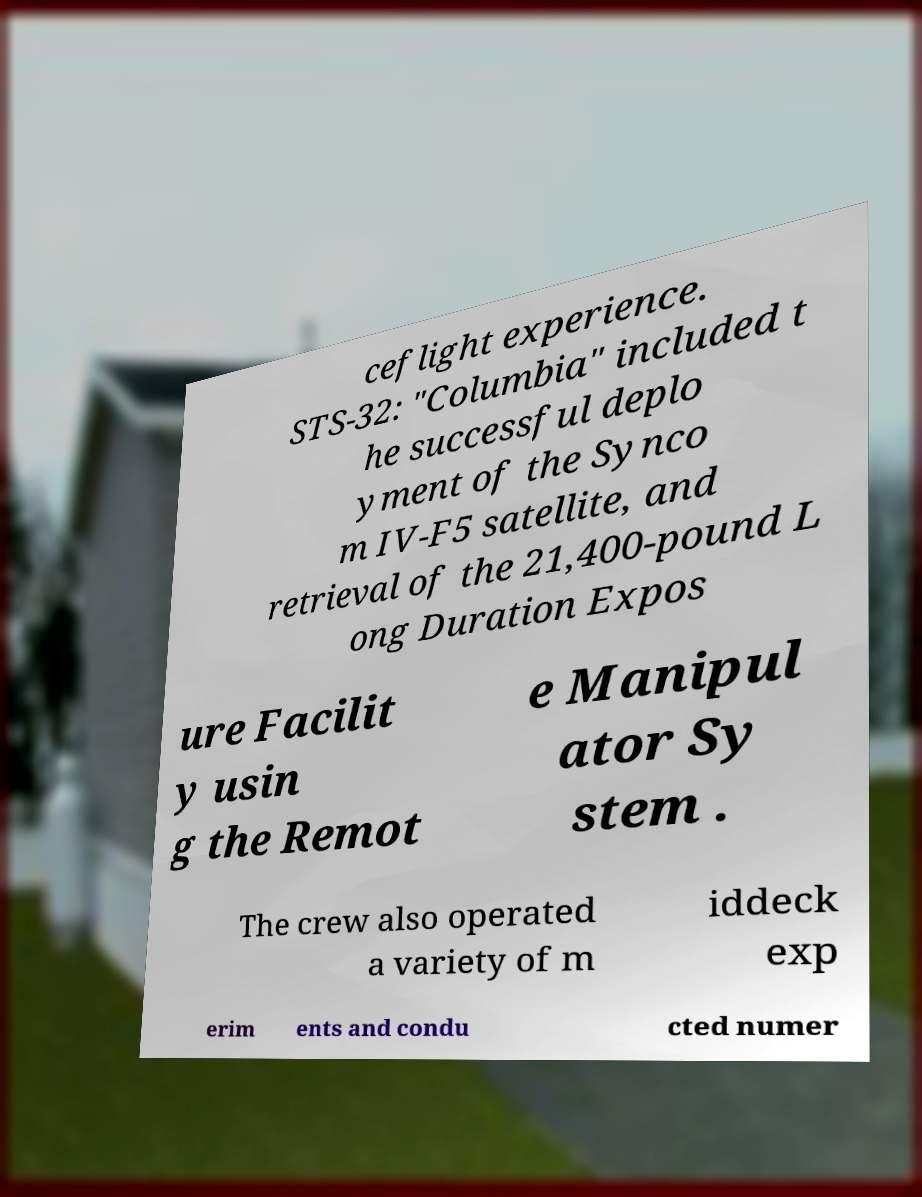Can you read and provide the text displayed in the image?This photo seems to have some interesting text. Can you extract and type it out for me? ceflight experience. STS-32: "Columbia" included t he successful deplo yment of the Synco m IV-F5 satellite, and retrieval of the 21,400-pound L ong Duration Expos ure Facilit y usin g the Remot e Manipul ator Sy stem . The crew also operated a variety of m iddeck exp erim ents and condu cted numer 